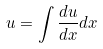Convert formula to latex. <formula><loc_0><loc_0><loc_500><loc_500>u = \int \frac { d u } { d x } d x</formula> 